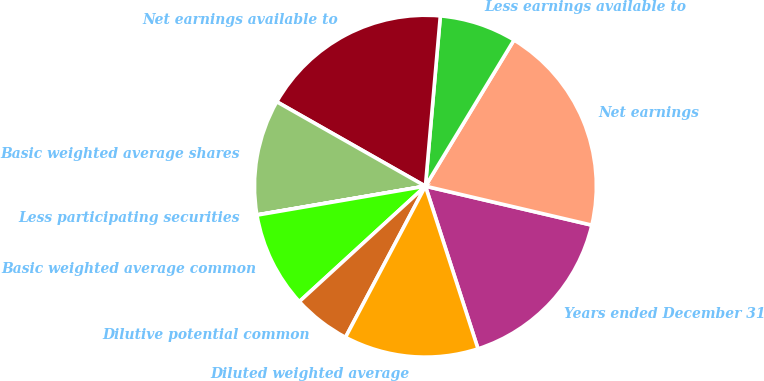<chart> <loc_0><loc_0><loc_500><loc_500><pie_chart><fcel>Years ended December 31<fcel>Net earnings<fcel>Less earnings available to<fcel>Net earnings available to<fcel>Basic weighted average shares<fcel>Less participating securities<fcel>Basic weighted average common<fcel>Dilutive potential common<fcel>Diluted weighted average<nl><fcel>16.36%<fcel>19.99%<fcel>7.28%<fcel>18.17%<fcel>10.91%<fcel>0.02%<fcel>9.09%<fcel>5.46%<fcel>12.72%<nl></chart> 